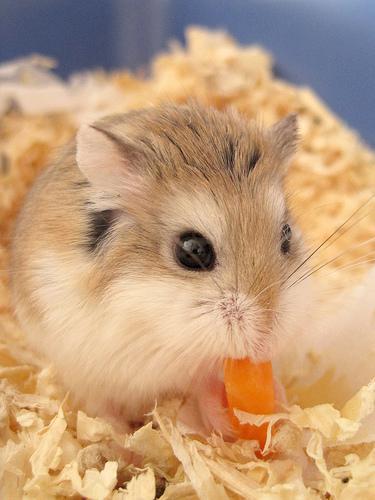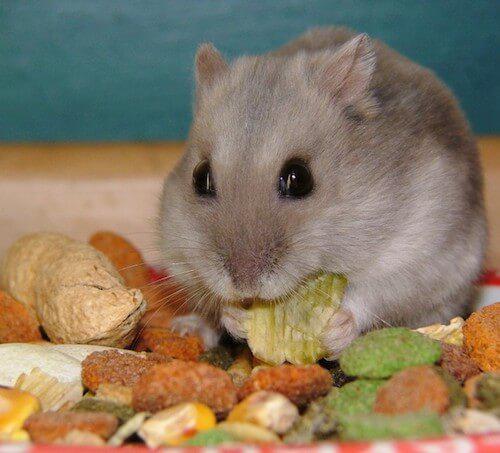The first image is the image on the left, the second image is the image on the right. For the images shown, is this caption "There are two hamsters who are eating food." true? Answer yes or no. Yes. The first image is the image on the left, the second image is the image on the right. Given the left and right images, does the statement "The food in the left image is green in color." hold true? Answer yes or no. No. 